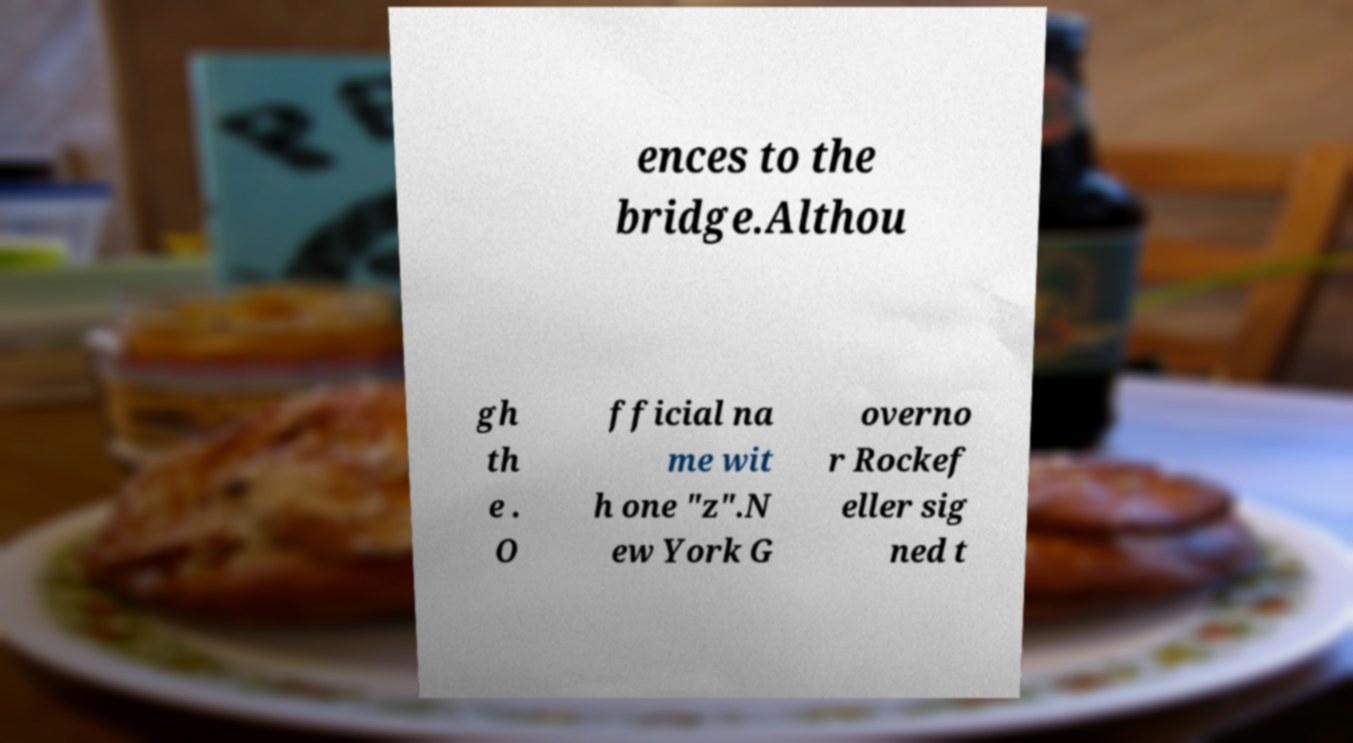There's text embedded in this image that I need extracted. Can you transcribe it verbatim? ences to the bridge.Althou gh th e . O fficial na me wit h one "z".N ew York G overno r Rockef eller sig ned t 